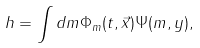<formula> <loc_0><loc_0><loc_500><loc_500>h = \int d m \Phi _ { m } ( t , \vec { x } ) \Psi ( m , y ) ,</formula> 